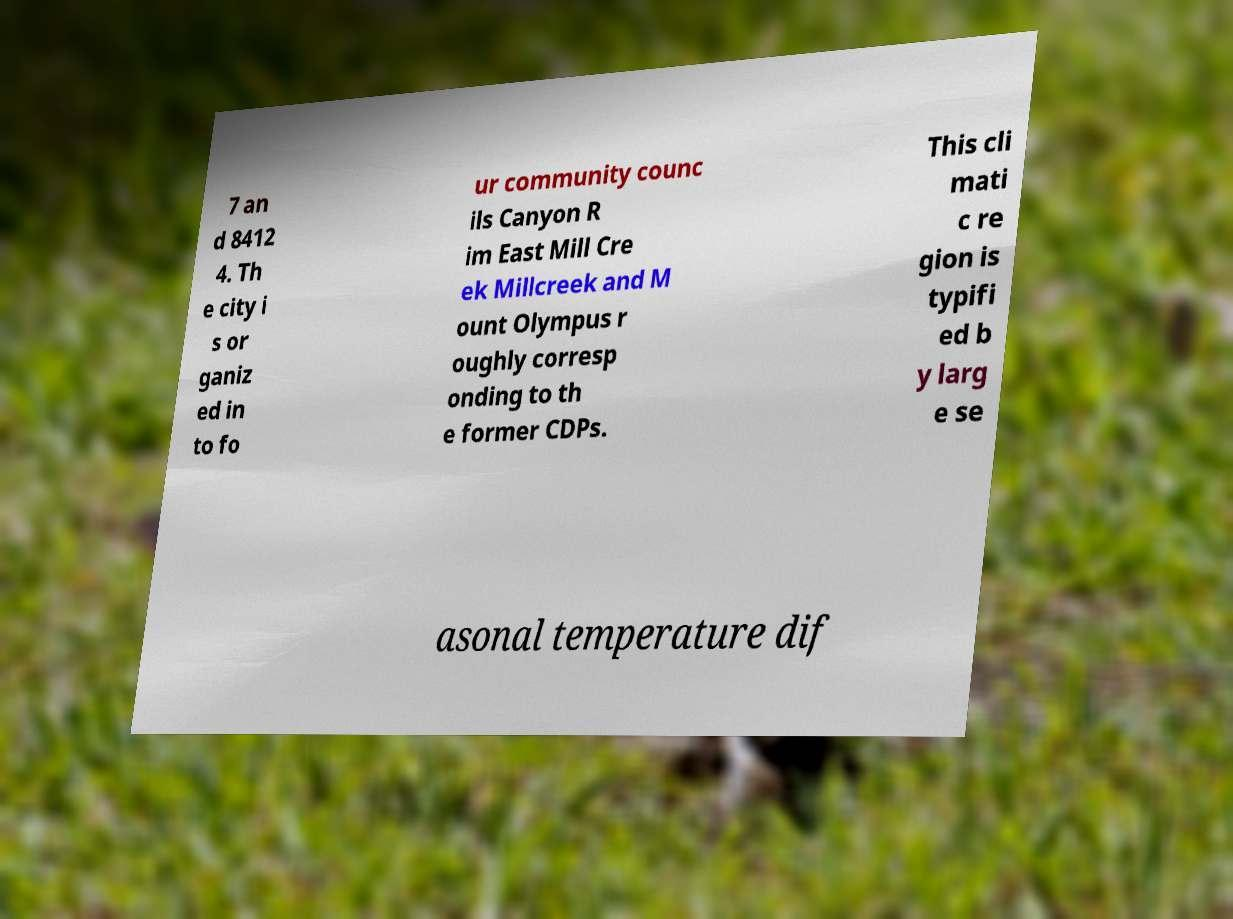Can you accurately transcribe the text from the provided image for me? 7 an d 8412 4. Th e city i s or ganiz ed in to fo ur community counc ils Canyon R im East Mill Cre ek Millcreek and M ount Olympus r oughly corresp onding to th e former CDPs. This cli mati c re gion is typifi ed b y larg e se asonal temperature dif 